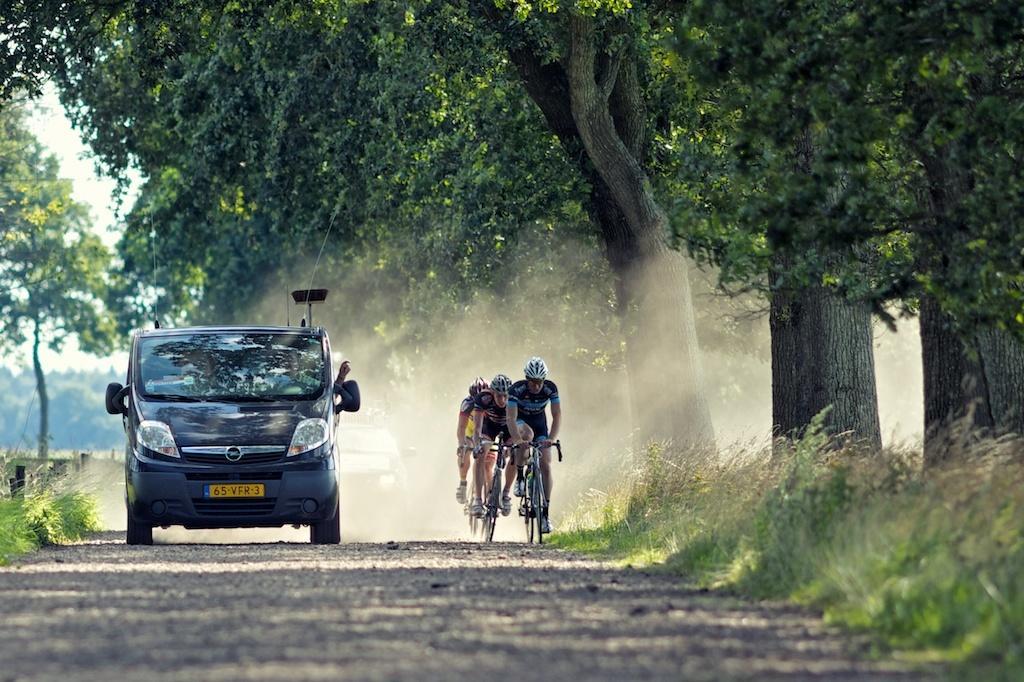How would you summarize this image in a sentence or two? In this image I see a vehicle and 3 persons who are on a cycle and all of them are on the road, I can also see grass and the trees in the background. 